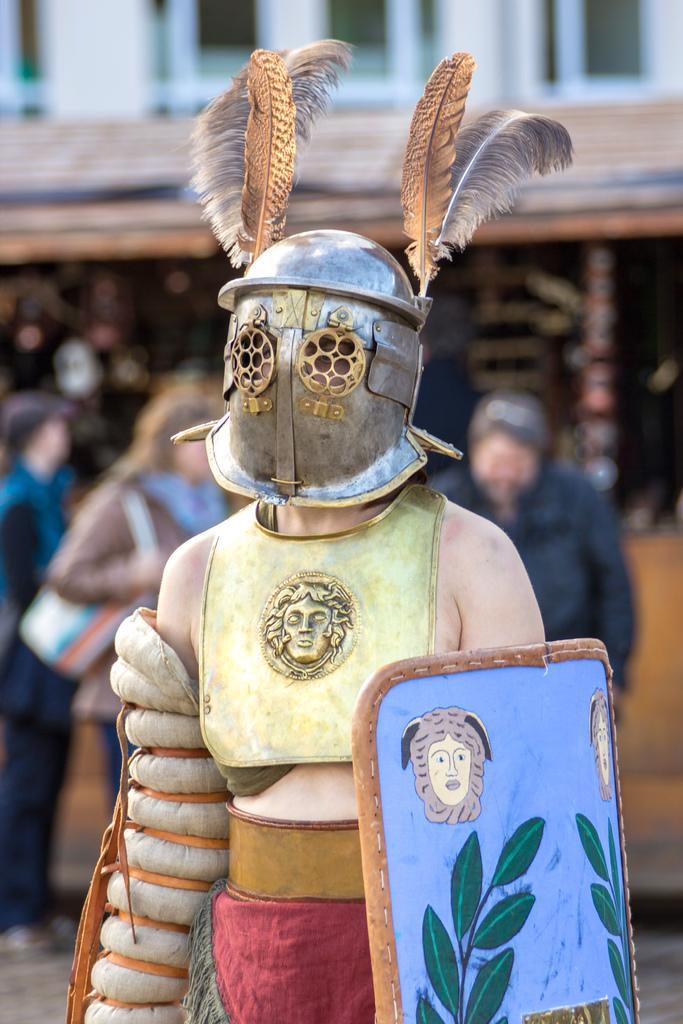In one or two sentences, can you explain what this image depicts? In this image there is a woman she is wearing shields, behind her there are two men and a woman, the background is blurry. 